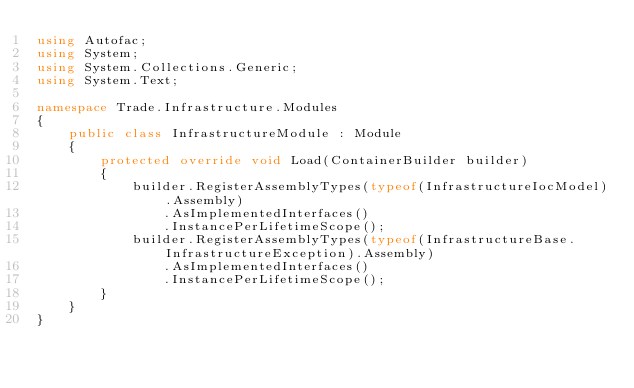Convert code to text. <code><loc_0><loc_0><loc_500><loc_500><_C#_>using Autofac;
using System;
using System.Collections.Generic;
using System.Text;

namespace Trade.Infrastructure.Modules
{
    public class InfrastructureModule : Module
    {
        protected override void Load(ContainerBuilder builder)
        {
            builder.RegisterAssemblyTypes(typeof(InfrastructureIocModel).Assembly)
                .AsImplementedInterfaces()
                .InstancePerLifetimeScope();
            builder.RegisterAssemblyTypes(typeof(InfrastructureBase.InfrastructureException).Assembly)
                .AsImplementedInterfaces()
                .InstancePerLifetimeScope();
        }
    }
}
</code> 